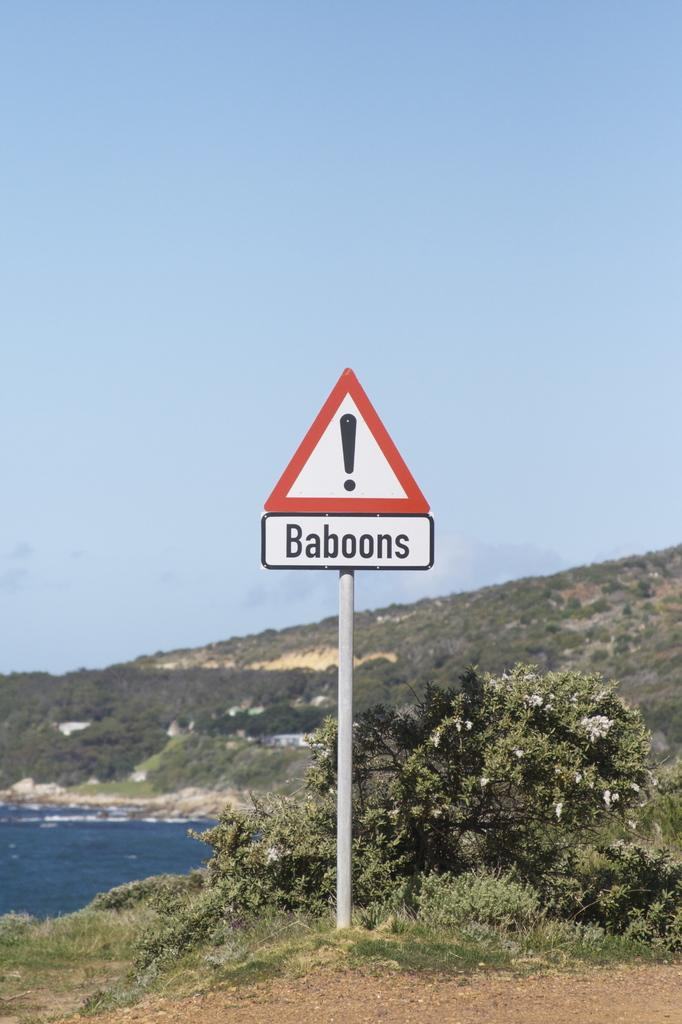Provide a one-sentence caption for the provided image. A hazard sign is outside that warns of baboons. 